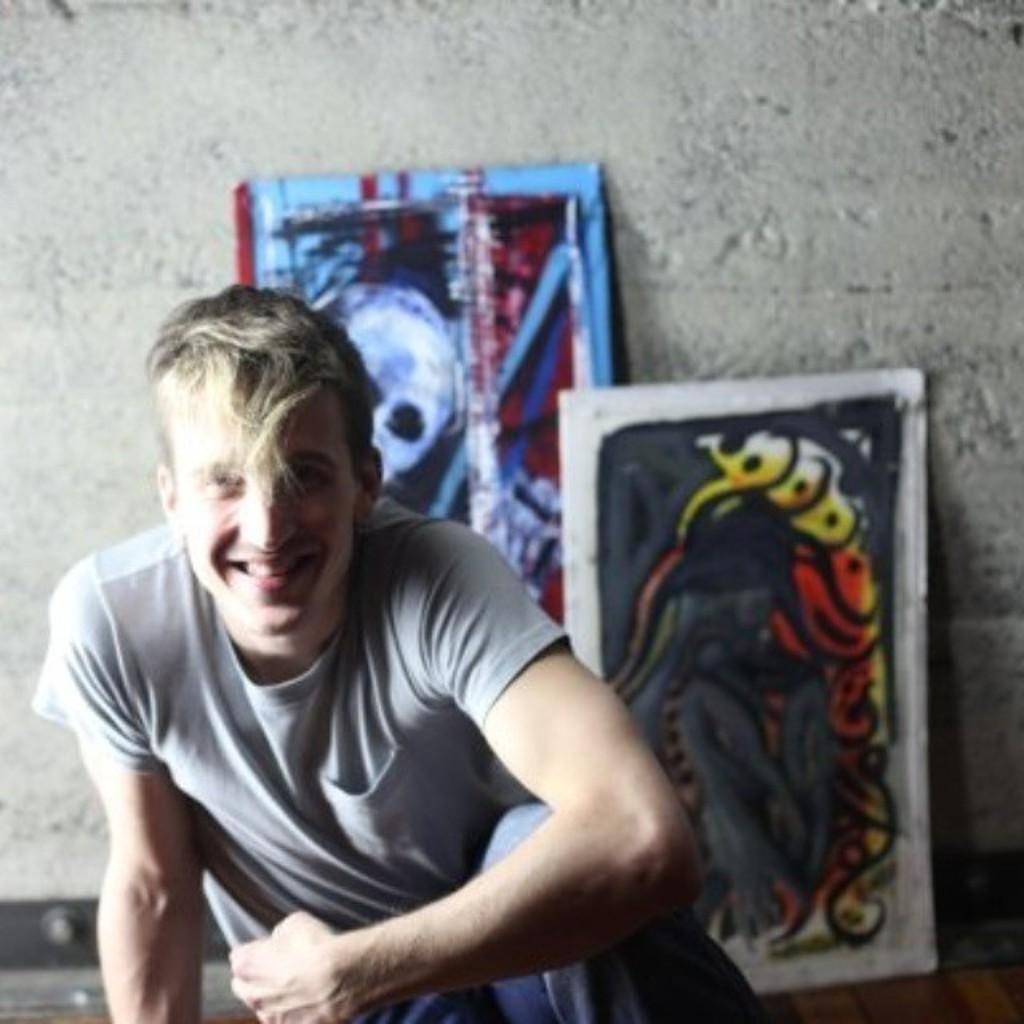What is the main subject of the image? There is a man in the image. What is the man doing in the image? The man is sitting. What is the man's facial expression in the image? The man is smiling. What can be seen hanging on the wall in the image? There are frames visible in the image. What type of background is present in the image? There is a wall in the image. What type of toothbrush is the man using in the image? There is no toothbrush present in the image. How does the man's mouth expand while he is sitting in the image? The man's mouth does not expand in the image; he is simply smiling. 